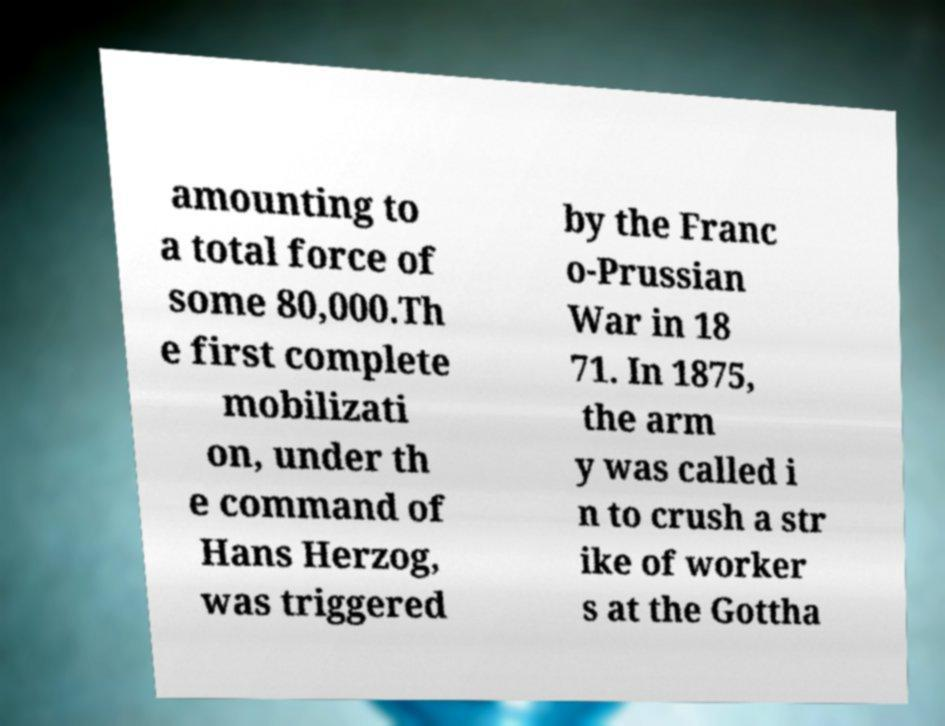What messages or text are displayed in this image? I need them in a readable, typed format. amounting to a total force of some 80,000.Th e first complete mobilizati on, under th e command of Hans Herzog, was triggered by the Franc o-Prussian War in 18 71. In 1875, the arm y was called i n to crush a str ike of worker s at the Gottha 